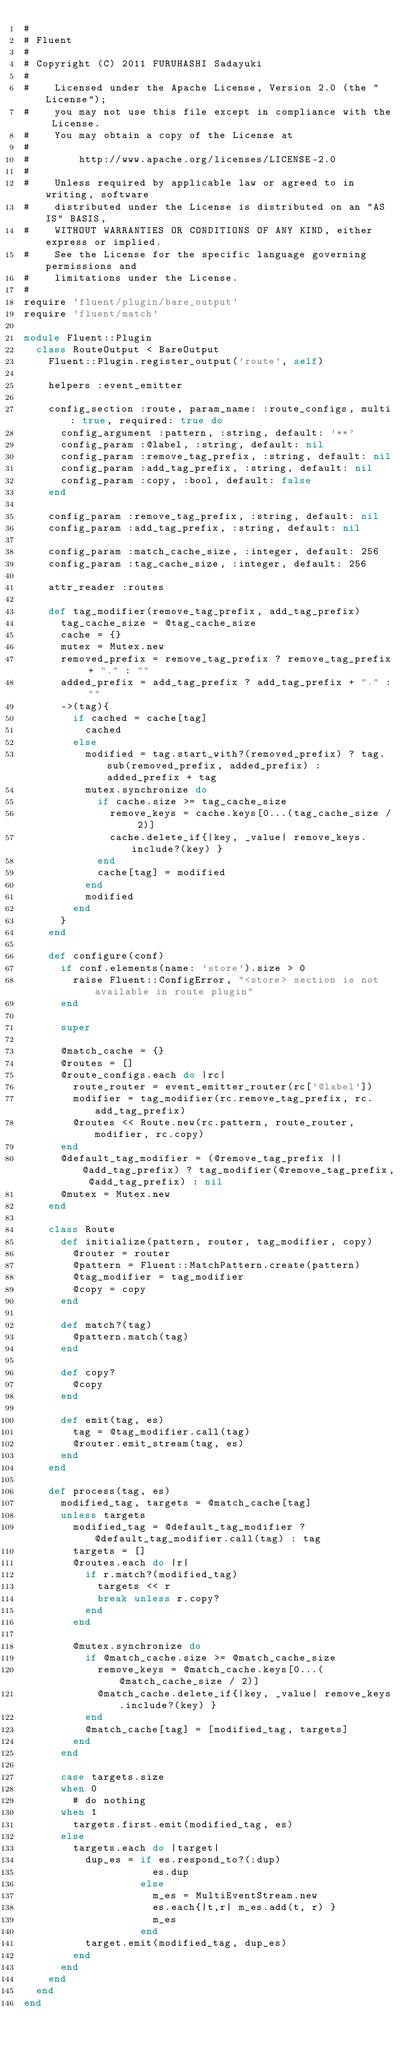<code> <loc_0><loc_0><loc_500><loc_500><_Ruby_>#
# Fluent
#
# Copyright (C) 2011 FURUHASHI Sadayuki
#
#    Licensed under the Apache License, Version 2.0 (the "License");
#    you may not use this file except in compliance with the License.
#    You may obtain a copy of the License at
#
#        http://www.apache.org/licenses/LICENSE-2.0
#
#    Unless required by applicable law or agreed to in writing, software
#    distributed under the License is distributed on an "AS IS" BASIS,
#    WITHOUT WARRANTIES OR CONDITIONS OF ANY KIND, either express or implied.
#    See the License for the specific language governing permissions and
#    limitations under the License.
#
require 'fluent/plugin/bare_output'
require 'fluent/match'

module Fluent::Plugin
  class RouteOutput < BareOutput
    Fluent::Plugin.register_output('route', self)

    helpers :event_emitter

    config_section :route, param_name: :route_configs, multi: true, required: true do
      config_argument :pattern, :string, default: '**'
      config_param :@label, :string, default: nil
      config_param :remove_tag_prefix, :string, default: nil
      config_param :add_tag_prefix, :string, default: nil
      config_param :copy, :bool, default: false
    end

    config_param :remove_tag_prefix, :string, default: nil
    config_param :add_tag_prefix, :string, default: nil

    config_param :match_cache_size, :integer, default: 256
    config_param :tag_cache_size, :integer, default: 256

    attr_reader :routes

    def tag_modifier(remove_tag_prefix, add_tag_prefix)
      tag_cache_size = @tag_cache_size
      cache = {}
      mutex = Mutex.new
      removed_prefix = remove_tag_prefix ? remove_tag_prefix + "." : ""
      added_prefix = add_tag_prefix ? add_tag_prefix + "." : ""
      ->(tag){
        if cached = cache[tag]
          cached
        else
          modified = tag.start_with?(removed_prefix) ? tag.sub(removed_prefix, added_prefix) : added_prefix + tag
          mutex.synchronize do
            if cache.size >= tag_cache_size
              remove_keys = cache.keys[0...(tag_cache_size / 2)]
              cache.delete_if{|key, _value| remove_keys.include?(key) }
            end
            cache[tag] = modified
          end
          modified
        end
      }
    end

    def configure(conf)
      if conf.elements(name: 'store').size > 0
        raise Fluent::ConfigError, "<store> section is not available in route plugin"
      end

      super

      @match_cache = {}
      @routes = []
      @route_configs.each do |rc|
        route_router = event_emitter_router(rc['@label'])
        modifier = tag_modifier(rc.remove_tag_prefix, rc.add_tag_prefix)
        @routes << Route.new(rc.pattern, route_router, modifier, rc.copy)
      end
      @default_tag_modifier = (@remove_tag_prefix || @add_tag_prefix) ? tag_modifier(@remove_tag_prefix, @add_tag_prefix) : nil
      @mutex = Mutex.new
    end

    class Route
      def initialize(pattern, router, tag_modifier, copy)
        @router = router
        @pattern = Fluent::MatchPattern.create(pattern)
        @tag_modifier = tag_modifier
        @copy = copy
      end

      def match?(tag)
        @pattern.match(tag)
      end

      def copy?
        @copy
      end

      def emit(tag, es)
        tag = @tag_modifier.call(tag)
        @router.emit_stream(tag, es)
      end
    end

    def process(tag, es)
      modified_tag, targets = @match_cache[tag]
      unless targets
        modified_tag = @default_tag_modifier ? @default_tag_modifier.call(tag) : tag
        targets = []
        @routes.each do |r|
          if r.match?(modified_tag)
            targets << r
            break unless r.copy?
          end
        end

        @mutex.synchronize do
          if @match_cache.size >= @match_cache_size
            remove_keys = @match_cache.keys[0...(@match_cache_size / 2)]
            @match_cache.delete_if{|key, _value| remove_keys.include?(key) }
          end
          @match_cache[tag] = [modified_tag, targets]
        end
      end

      case targets.size
      when 0
        # do nothing
      when 1
        targets.first.emit(modified_tag, es)
      else
        targets.each do |target|
          dup_es = if es.respond_to?(:dup)
                     es.dup
                   else
                     m_es = MultiEventStream.new
                     es.each{|t,r| m_es.add(t, r) }
                     m_es
                   end
          target.emit(modified_tag, dup_es)
        end
      end
    end
  end
end
</code> 